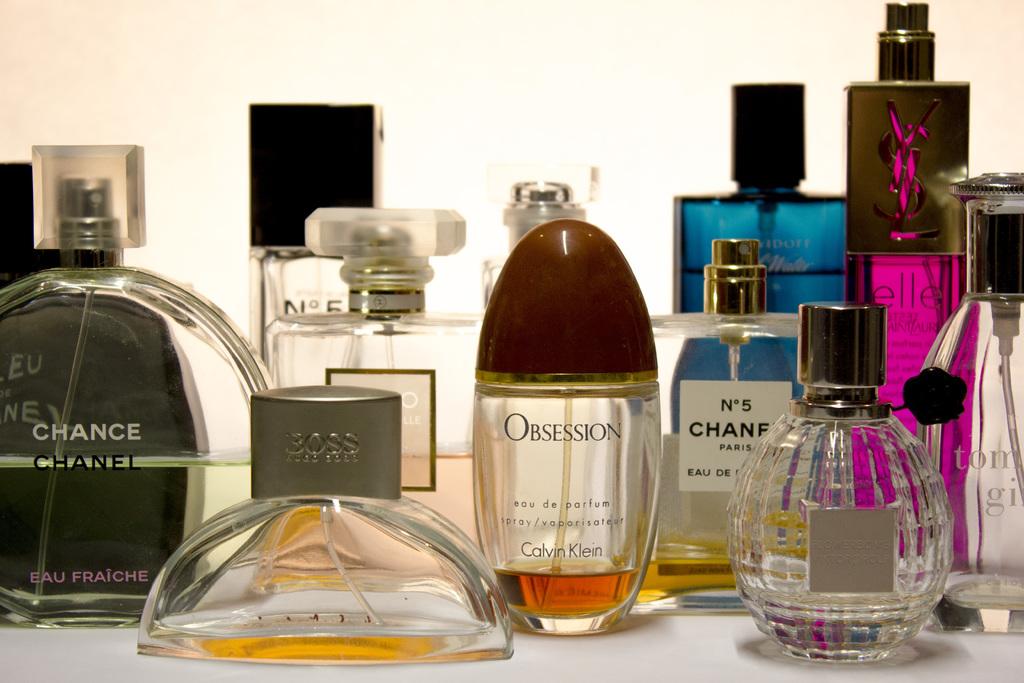Who makes perfume no. 5?
Keep it short and to the point. Chanel. 